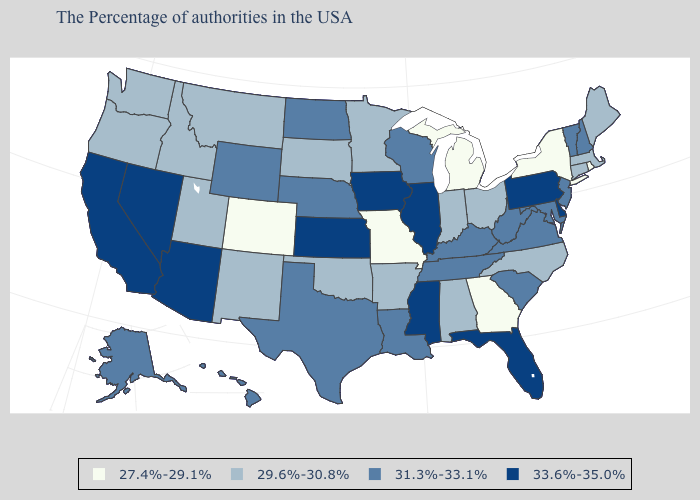Name the states that have a value in the range 31.3%-33.1%?
Concise answer only. New Hampshire, Vermont, New Jersey, Maryland, Virginia, South Carolina, West Virginia, Kentucky, Tennessee, Wisconsin, Louisiana, Nebraska, Texas, North Dakota, Wyoming, Alaska, Hawaii. Name the states that have a value in the range 29.6%-30.8%?
Give a very brief answer. Maine, Massachusetts, Connecticut, North Carolina, Ohio, Indiana, Alabama, Arkansas, Minnesota, Oklahoma, South Dakota, New Mexico, Utah, Montana, Idaho, Washington, Oregon. What is the value of Alaska?
Write a very short answer. 31.3%-33.1%. Does the map have missing data?
Write a very short answer. No. Name the states that have a value in the range 33.6%-35.0%?
Keep it brief. Delaware, Pennsylvania, Florida, Illinois, Mississippi, Iowa, Kansas, Arizona, Nevada, California. Which states have the lowest value in the MidWest?
Concise answer only. Michigan, Missouri. Does the map have missing data?
Keep it brief. No. Does Kansas have the lowest value in the MidWest?
Write a very short answer. No. Is the legend a continuous bar?
Write a very short answer. No. Does Illinois have the lowest value in the MidWest?
Answer briefly. No. Does Michigan have a lower value than Arizona?
Be succinct. Yes. What is the lowest value in states that border Wisconsin?
Answer briefly. 27.4%-29.1%. Name the states that have a value in the range 33.6%-35.0%?
Answer briefly. Delaware, Pennsylvania, Florida, Illinois, Mississippi, Iowa, Kansas, Arizona, Nevada, California. Does Idaho have a lower value than Missouri?
Short answer required. No. Name the states that have a value in the range 29.6%-30.8%?
Quick response, please. Maine, Massachusetts, Connecticut, North Carolina, Ohio, Indiana, Alabama, Arkansas, Minnesota, Oklahoma, South Dakota, New Mexico, Utah, Montana, Idaho, Washington, Oregon. 